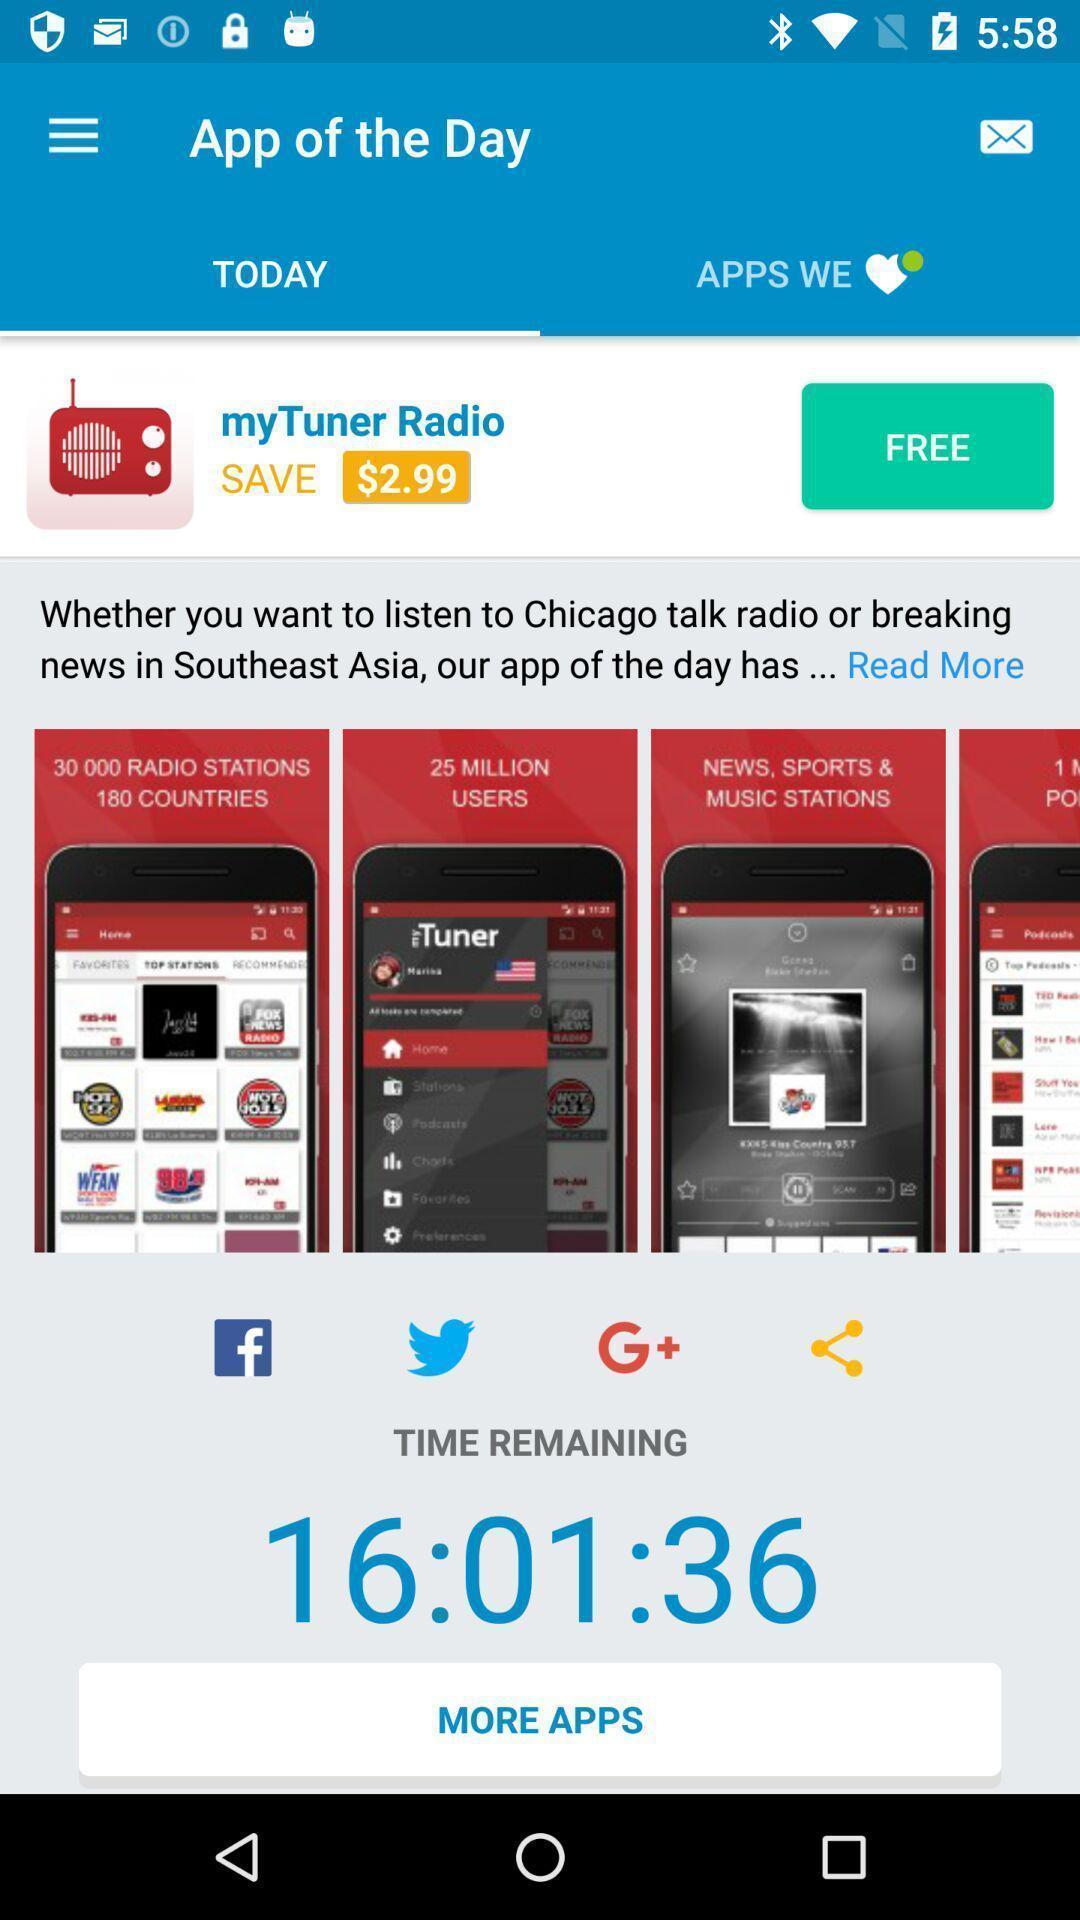Please provide a description for this image. Screen displaying app of the day. 